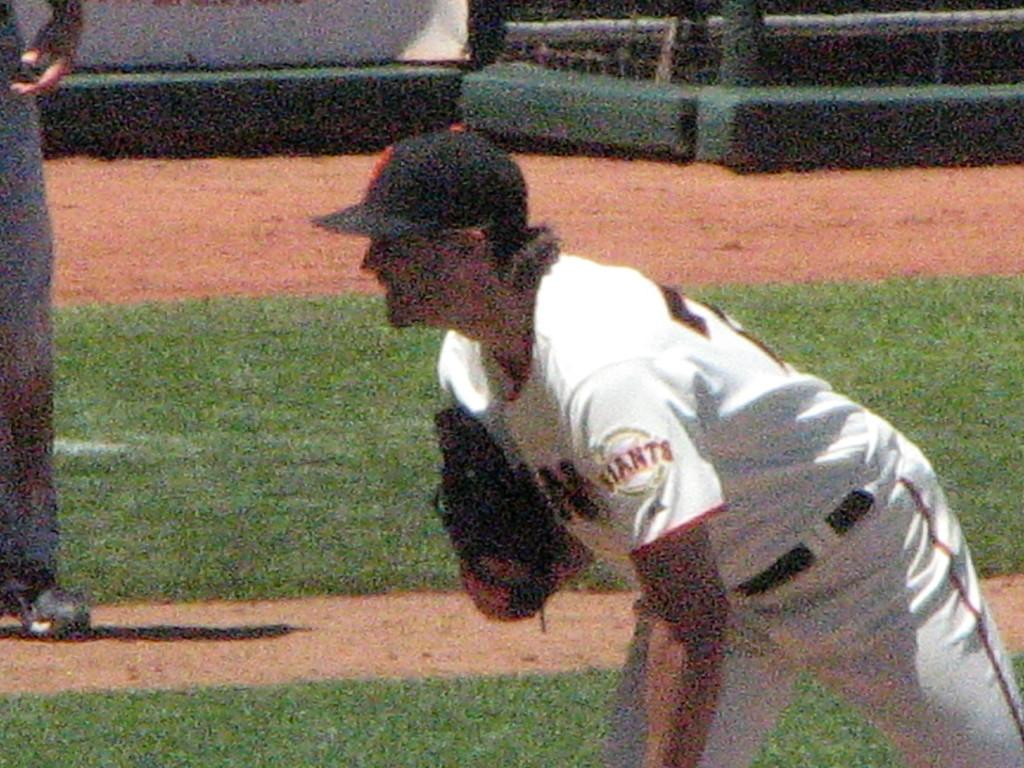Provide a one-sentence caption for the provided image. A Giants player is leaning forward, ready for the play. 